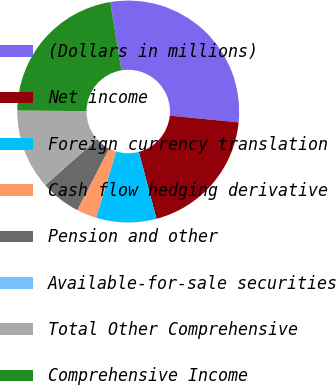<chart> <loc_0><loc_0><loc_500><loc_500><pie_chart><fcel>(Dollars in millions)<fcel>Net income<fcel>Foreign currency translation<fcel>Cash flow hedging derivative<fcel>Pension and other<fcel>Available-for-sale securities<fcel>Total Other Comprehensive<fcel>Comprehensive Income<nl><fcel>29.16%<fcel>19.34%<fcel>8.76%<fcel>2.93%<fcel>5.85%<fcel>0.02%<fcel>11.68%<fcel>22.26%<nl></chart> 